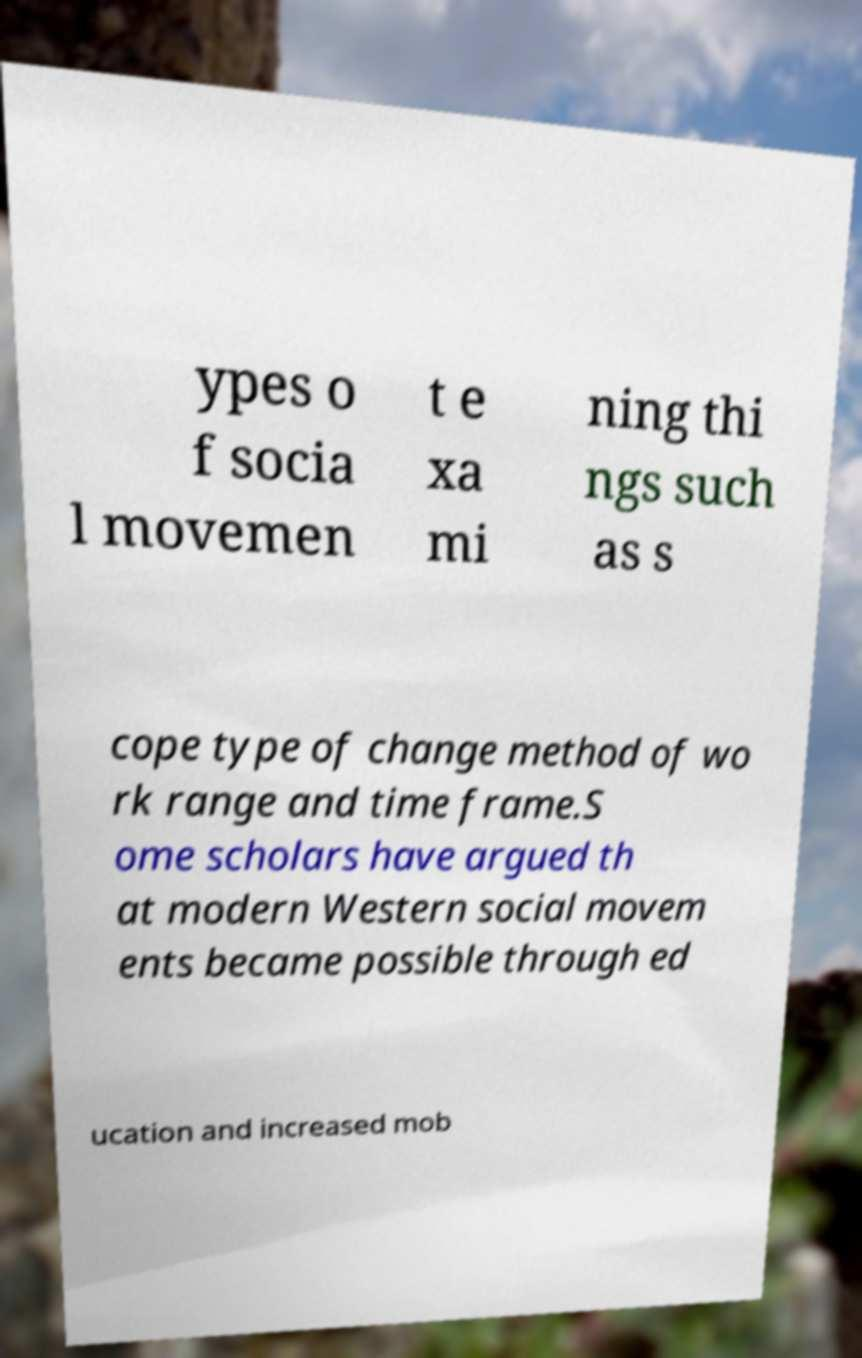Could you extract and type out the text from this image? ypes o f socia l movemen t e xa mi ning thi ngs such as s cope type of change method of wo rk range and time frame.S ome scholars have argued th at modern Western social movem ents became possible through ed ucation and increased mob 